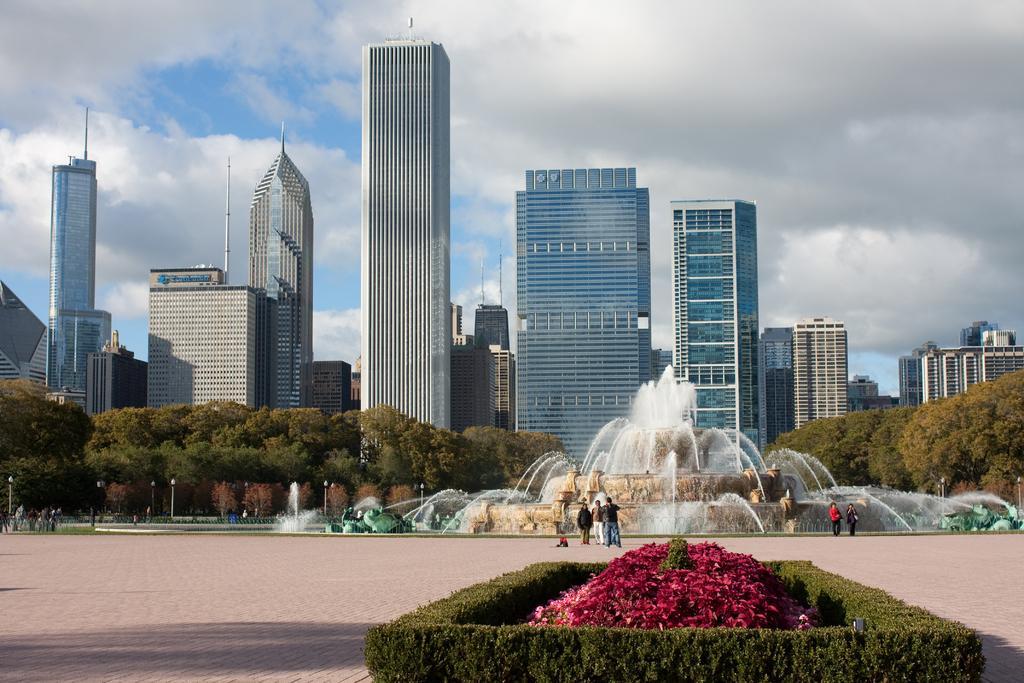Can you describe this image briefly? In this picture I can see there are a few plants and they have a pink color flowers, there are few more plants around it. There is a huge fountain in the backdrop and there are a few people standing and few are walking on left side. In the backdrop, there are trees, buildings and the sky is clear. 